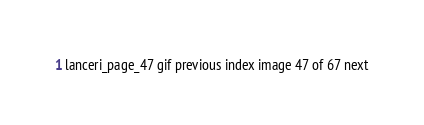<code> <loc_0><loc_0><loc_500><loc_500><_HTML_>lanceri_page_47 gif previous index image 47 of 67 next
</code> 